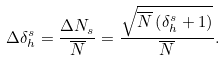Convert formula to latex. <formula><loc_0><loc_0><loc_500><loc_500>\Delta \delta _ { h } ^ { s } = \frac { \Delta N _ { s } } { \overline { N } } = \frac { \sqrt { \overline { N } \left ( \delta _ { h } ^ { s } + 1 \right ) } } { \overline { N } } .</formula> 